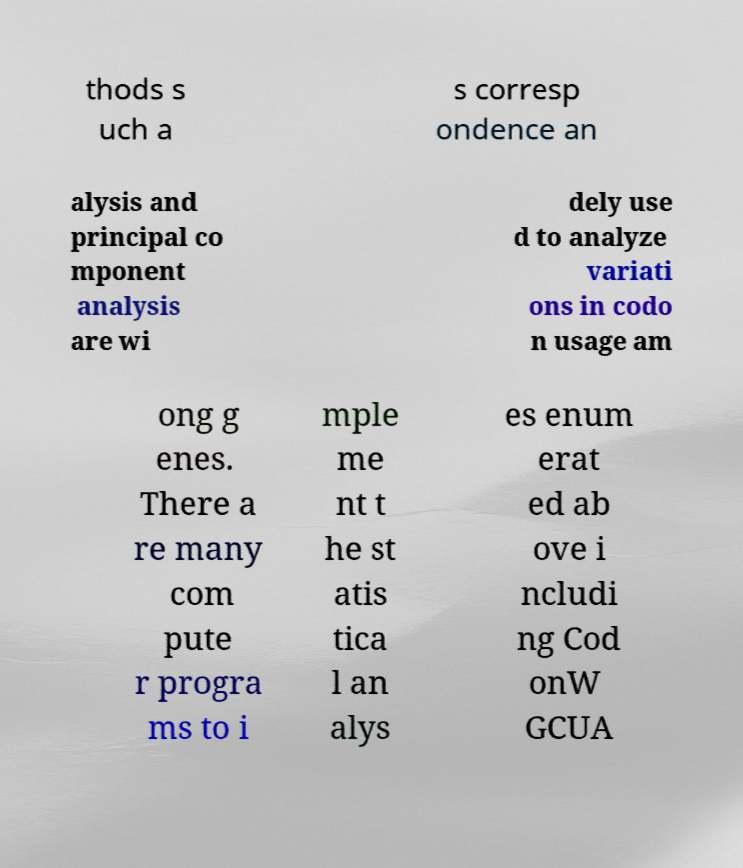Please read and relay the text visible in this image. What does it say? thods s uch a s corresp ondence an alysis and principal co mponent analysis are wi dely use d to analyze variati ons in codo n usage am ong g enes. There a re many com pute r progra ms to i mple me nt t he st atis tica l an alys es enum erat ed ab ove i ncludi ng Cod onW GCUA 